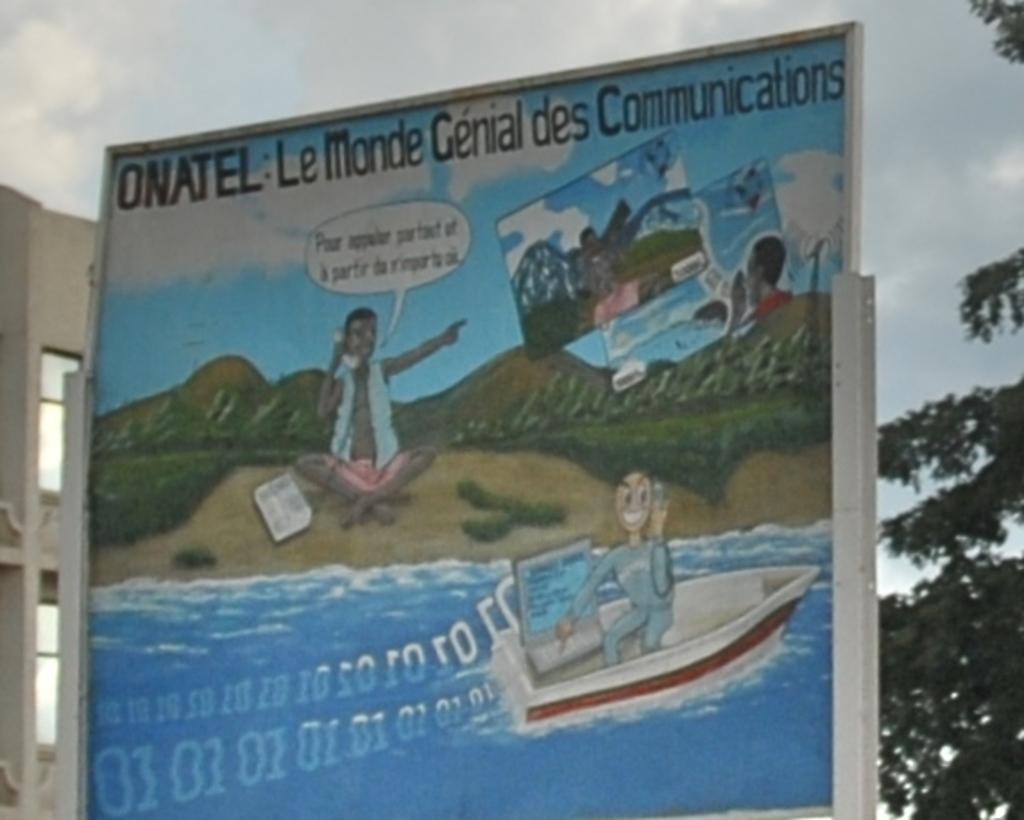What brand is this advertising?
Your answer should be very brief. Onatel. In what language is the advertisment?
Offer a terse response. Unanswerable. 